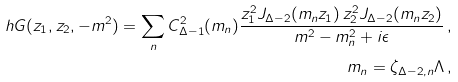<formula> <loc_0><loc_0><loc_500><loc_500>\ h { G } ( z _ { 1 } , z _ { 2 } , - m ^ { 2 } ) = \sum _ { n } C ^ { 2 } _ { \Delta - 1 } ( m _ { n } ) \frac { z _ { 1 } ^ { 2 } J _ { \Delta - 2 } ( m _ { n } z _ { 1 } ) \, z _ { 2 } ^ { 2 } J _ { \Delta - 2 } ( m _ { n } z _ { 2 } ) } { m ^ { 2 } - m _ { n } ^ { 2 } + i \epsilon } \, , \\ m _ { n } = \zeta _ { \Delta - 2 , n } \Lambda \, ,</formula> 